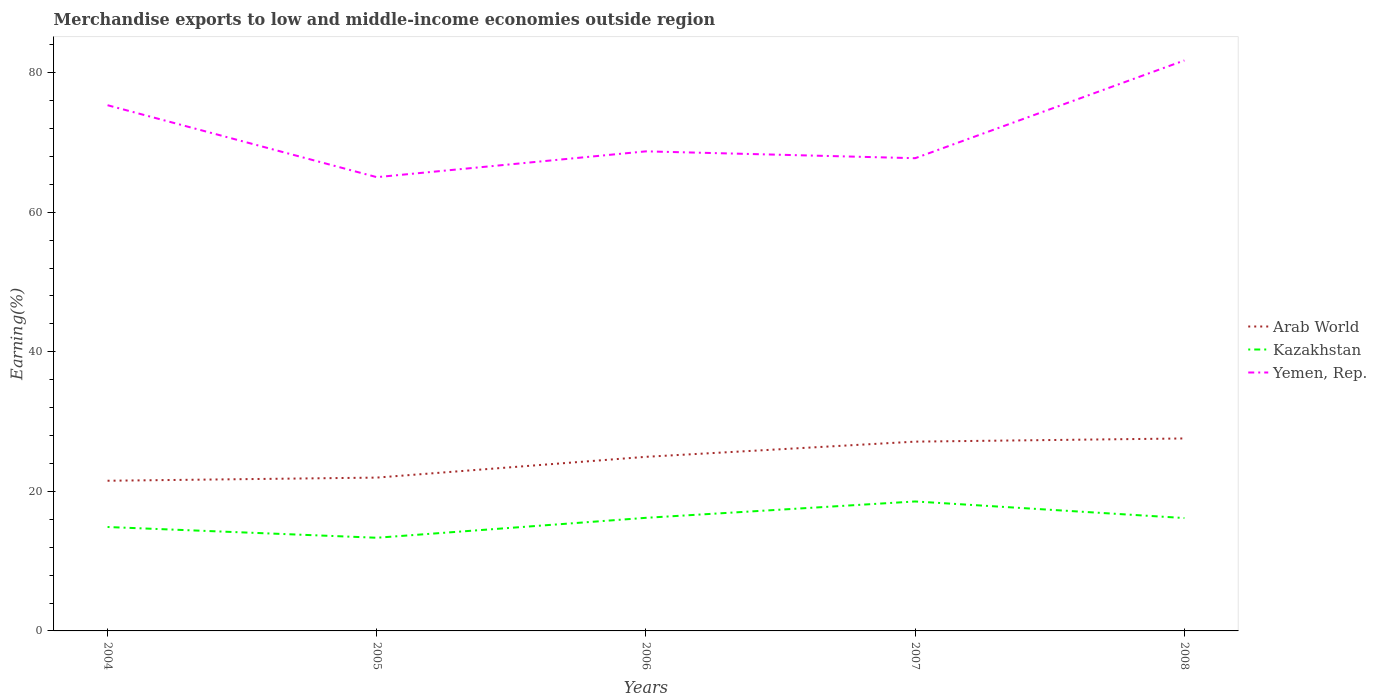How many different coloured lines are there?
Make the answer very short. 3. Does the line corresponding to Kazakhstan intersect with the line corresponding to Yemen, Rep.?
Give a very brief answer. No. Across all years, what is the maximum percentage of amount earned from merchandise exports in Arab World?
Provide a short and direct response. 21.52. In which year was the percentage of amount earned from merchandise exports in Arab World maximum?
Provide a succinct answer. 2004. What is the total percentage of amount earned from merchandise exports in Kazakhstan in the graph?
Ensure brevity in your answer.  -3.66. What is the difference between the highest and the second highest percentage of amount earned from merchandise exports in Arab World?
Give a very brief answer. 6.06. What is the difference between two consecutive major ticks on the Y-axis?
Ensure brevity in your answer.  20. Are the values on the major ticks of Y-axis written in scientific E-notation?
Your response must be concise. No. Does the graph contain any zero values?
Provide a succinct answer. No. Where does the legend appear in the graph?
Your answer should be very brief. Center right. How many legend labels are there?
Ensure brevity in your answer.  3. How are the legend labels stacked?
Keep it short and to the point. Vertical. What is the title of the graph?
Make the answer very short. Merchandise exports to low and middle-income economies outside region. Does "Latin America(developing only)" appear as one of the legend labels in the graph?
Provide a succinct answer. No. What is the label or title of the Y-axis?
Ensure brevity in your answer.  Earning(%). What is the Earning(%) in Arab World in 2004?
Keep it short and to the point. 21.52. What is the Earning(%) in Kazakhstan in 2004?
Offer a terse response. 14.89. What is the Earning(%) of Yemen, Rep. in 2004?
Give a very brief answer. 75.33. What is the Earning(%) of Arab World in 2005?
Make the answer very short. 21.97. What is the Earning(%) in Kazakhstan in 2005?
Keep it short and to the point. 13.35. What is the Earning(%) in Yemen, Rep. in 2005?
Provide a short and direct response. 65.02. What is the Earning(%) in Arab World in 2006?
Your answer should be very brief. 24.95. What is the Earning(%) in Kazakhstan in 2006?
Make the answer very short. 16.21. What is the Earning(%) in Yemen, Rep. in 2006?
Offer a very short reply. 68.72. What is the Earning(%) of Arab World in 2007?
Your answer should be compact. 27.12. What is the Earning(%) in Kazakhstan in 2007?
Your response must be concise. 18.55. What is the Earning(%) of Yemen, Rep. in 2007?
Offer a very short reply. 67.73. What is the Earning(%) in Arab World in 2008?
Ensure brevity in your answer.  27.58. What is the Earning(%) of Kazakhstan in 2008?
Your response must be concise. 16.17. What is the Earning(%) in Yemen, Rep. in 2008?
Make the answer very short. 81.74. Across all years, what is the maximum Earning(%) in Arab World?
Provide a succinct answer. 27.58. Across all years, what is the maximum Earning(%) in Kazakhstan?
Provide a succinct answer. 18.55. Across all years, what is the maximum Earning(%) of Yemen, Rep.?
Make the answer very short. 81.74. Across all years, what is the minimum Earning(%) of Arab World?
Give a very brief answer. 21.52. Across all years, what is the minimum Earning(%) in Kazakhstan?
Your response must be concise. 13.35. Across all years, what is the minimum Earning(%) of Yemen, Rep.?
Your response must be concise. 65.02. What is the total Earning(%) in Arab World in the graph?
Ensure brevity in your answer.  123.14. What is the total Earning(%) of Kazakhstan in the graph?
Your response must be concise. 79.17. What is the total Earning(%) in Yemen, Rep. in the graph?
Provide a short and direct response. 358.54. What is the difference between the Earning(%) in Arab World in 2004 and that in 2005?
Provide a succinct answer. -0.45. What is the difference between the Earning(%) of Kazakhstan in 2004 and that in 2005?
Your answer should be very brief. 1.54. What is the difference between the Earning(%) of Yemen, Rep. in 2004 and that in 2005?
Ensure brevity in your answer.  10.31. What is the difference between the Earning(%) in Arab World in 2004 and that in 2006?
Your answer should be compact. -3.43. What is the difference between the Earning(%) in Kazakhstan in 2004 and that in 2006?
Offer a very short reply. -1.32. What is the difference between the Earning(%) of Yemen, Rep. in 2004 and that in 2006?
Your response must be concise. 6.61. What is the difference between the Earning(%) of Arab World in 2004 and that in 2007?
Provide a succinct answer. -5.6. What is the difference between the Earning(%) of Kazakhstan in 2004 and that in 2007?
Make the answer very short. -3.66. What is the difference between the Earning(%) in Yemen, Rep. in 2004 and that in 2007?
Offer a terse response. 7.59. What is the difference between the Earning(%) of Arab World in 2004 and that in 2008?
Give a very brief answer. -6.06. What is the difference between the Earning(%) in Kazakhstan in 2004 and that in 2008?
Make the answer very short. -1.28. What is the difference between the Earning(%) of Yemen, Rep. in 2004 and that in 2008?
Your answer should be very brief. -6.42. What is the difference between the Earning(%) of Arab World in 2005 and that in 2006?
Provide a succinct answer. -2.98. What is the difference between the Earning(%) of Kazakhstan in 2005 and that in 2006?
Offer a terse response. -2.86. What is the difference between the Earning(%) in Yemen, Rep. in 2005 and that in 2006?
Your answer should be compact. -3.7. What is the difference between the Earning(%) of Arab World in 2005 and that in 2007?
Provide a succinct answer. -5.15. What is the difference between the Earning(%) of Kazakhstan in 2005 and that in 2007?
Provide a succinct answer. -5.2. What is the difference between the Earning(%) of Yemen, Rep. in 2005 and that in 2007?
Provide a succinct answer. -2.72. What is the difference between the Earning(%) of Arab World in 2005 and that in 2008?
Your answer should be very brief. -5.61. What is the difference between the Earning(%) in Kazakhstan in 2005 and that in 2008?
Provide a short and direct response. -2.82. What is the difference between the Earning(%) in Yemen, Rep. in 2005 and that in 2008?
Provide a short and direct response. -16.72. What is the difference between the Earning(%) in Arab World in 2006 and that in 2007?
Make the answer very short. -2.18. What is the difference between the Earning(%) of Kazakhstan in 2006 and that in 2007?
Keep it short and to the point. -2.34. What is the difference between the Earning(%) of Yemen, Rep. in 2006 and that in 2007?
Your response must be concise. 0.98. What is the difference between the Earning(%) of Arab World in 2006 and that in 2008?
Your answer should be compact. -2.63. What is the difference between the Earning(%) of Kazakhstan in 2006 and that in 2008?
Offer a very short reply. 0.03. What is the difference between the Earning(%) in Yemen, Rep. in 2006 and that in 2008?
Ensure brevity in your answer.  -13.03. What is the difference between the Earning(%) in Arab World in 2007 and that in 2008?
Ensure brevity in your answer.  -0.46. What is the difference between the Earning(%) in Kazakhstan in 2007 and that in 2008?
Your response must be concise. 2.38. What is the difference between the Earning(%) in Yemen, Rep. in 2007 and that in 2008?
Your response must be concise. -14.01. What is the difference between the Earning(%) in Arab World in 2004 and the Earning(%) in Kazakhstan in 2005?
Provide a short and direct response. 8.17. What is the difference between the Earning(%) in Arab World in 2004 and the Earning(%) in Yemen, Rep. in 2005?
Your answer should be very brief. -43.5. What is the difference between the Earning(%) of Kazakhstan in 2004 and the Earning(%) of Yemen, Rep. in 2005?
Provide a short and direct response. -50.13. What is the difference between the Earning(%) in Arab World in 2004 and the Earning(%) in Kazakhstan in 2006?
Make the answer very short. 5.31. What is the difference between the Earning(%) of Arab World in 2004 and the Earning(%) of Yemen, Rep. in 2006?
Your answer should be compact. -47.2. What is the difference between the Earning(%) of Kazakhstan in 2004 and the Earning(%) of Yemen, Rep. in 2006?
Make the answer very short. -53.83. What is the difference between the Earning(%) of Arab World in 2004 and the Earning(%) of Kazakhstan in 2007?
Keep it short and to the point. 2.97. What is the difference between the Earning(%) in Arab World in 2004 and the Earning(%) in Yemen, Rep. in 2007?
Provide a short and direct response. -46.22. What is the difference between the Earning(%) of Kazakhstan in 2004 and the Earning(%) of Yemen, Rep. in 2007?
Make the answer very short. -52.84. What is the difference between the Earning(%) of Arab World in 2004 and the Earning(%) of Kazakhstan in 2008?
Make the answer very short. 5.35. What is the difference between the Earning(%) in Arab World in 2004 and the Earning(%) in Yemen, Rep. in 2008?
Provide a succinct answer. -60.22. What is the difference between the Earning(%) of Kazakhstan in 2004 and the Earning(%) of Yemen, Rep. in 2008?
Your answer should be compact. -66.85. What is the difference between the Earning(%) in Arab World in 2005 and the Earning(%) in Kazakhstan in 2006?
Offer a very short reply. 5.76. What is the difference between the Earning(%) of Arab World in 2005 and the Earning(%) of Yemen, Rep. in 2006?
Offer a terse response. -46.75. What is the difference between the Earning(%) in Kazakhstan in 2005 and the Earning(%) in Yemen, Rep. in 2006?
Your response must be concise. -55.37. What is the difference between the Earning(%) in Arab World in 2005 and the Earning(%) in Kazakhstan in 2007?
Give a very brief answer. 3.42. What is the difference between the Earning(%) in Arab World in 2005 and the Earning(%) in Yemen, Rep. in 2007?
Offer a very short reply. -45.77. What is the difference between the Earning(%) of Kazakhstan in 2005 and the Earning(%) of Yemen, Rep. in 2007?
Your response must be concise. -54.38. What is the difference between the Earning(%) of Arab World in 2005 and the Earning(%) of Kazakhstan in 2008?
Your answer should be compact. 5.8. What is the difference between the Earning(%) of Arab World in 2005 and the Earning(%) of Yemen, Rep. in 2008?
Your answer should be very brief. -59.77. What is the difference between the Earning(%) in Kazakhstan in 2005 and the Earning(%) in Yemen, Rep. in 2008?
Offer a terse response. -68.39. What is the difference between the Earning(%) in Arab World in 2006 and the Earning(%) in Kazakhstan in 2007?
Keep it short and to the point. 6.4. What is the difference between the Earning(%) of Arab World in 2006 and the Earning(%) of Yemen, Rep. in 2007?
Ensure brevity in your answer.  -42.79. What is the difference between the Earning(%) of Kazakhstan in 2006 and the Earning(%) of Yemen, Rep. in 2007?
Keep it short and to the point. -51.53. What is the difference between the Earning(%) of Arab World in 2006 and the Earning(%) of Kazakhstan in 2008?
Give a very brief answer. 8.77. What is the difference between the Earning(%) in Arab World in 2006 and the Earning(%) in Yemen, Rep. in 2008?
Provide a short and direct response. -56.8. What is the difference between the Earning(%) of Kazakhstan in 2006 and the Earning(%) of Yemen, Rep. in 2008?
Offer a very short reply. -65.54. What is the difference between the Earning(%) in Arab World in 2007 and the Earning(%) in Kazakhstan in 2008?
Give a very brief answer. 10.95. What is the difference between the Earning(%) of Arab World in 2007 and the Earning(%) of Yemen, Rep. in 2008?
Provide a succinct answer. -54.62. What is the difference between the Earning(%) of Kazakhstan in 2007 and the Earning(%) of Yemen, Rep. in 2008?
Offer a very short reply. -63.19. What is the average Earning(%) of Arab World per year?
Provide a succinct answer. 24.63. What is the average Earning(%) of Kazakhstan per year?
Your answer should be compact. 15.83. What is the average Earning(%) of Yemen, Rep. per year?
Provide a short and direct response. 71.71. In the year 2004, what is the difference between the Earning(%) of Arab World and Earning(%) of Kazakhstan?
Provide a succinct answer. 6.63. In the year 2004, what is the difference between the Earning(%) in Arab World and Earning(%) in Yemen, Rep.?
Provide a succinct answer. -53.81. In the year 2004, what is the difference between the Earning(%) in Kazakhstan and Earning(%) in Yemen, Rep.?
Provide a succinct answer. -60.44. In the year 2005, what is the difference between the Earning(%) in Arab World and Earning(%) in Kazakhstan?
Provide a succinct answer. 8.62. In the year 2005, what is the difference between the Earning(%) in Arab World and Earning(%) in Yemen, Rep.?
Keep it short and to the point. -43.05. In the year 2005, what is the difference between the Earning(%) of Kazakhstan and Earning(%) of Yemen, Rep.?
Your answer should be very brief. -51.67. In the year 2006, what is the difference between the Earning(%) in Arab World and Earning(%) in Kazakhstan?
Keep it short and to the point. 8.74. In the year 2006, what is the difference between the Earning(%) of Arab World and Earning(%) of Yemen, Rep.?
Ensure brevity in your answer.  -43.77. In the year 2006, what is the difference between the Earning(%) in Kazakhstan and Earning(%) in Yemen, Rep.?
Ensure brevity in your answer.  -52.51. In the year 2007, what is the difference between the Earning(%) of Arab World and Earning(%) of Kazakhstan?
Offer a terse response. 8.57. In the year 2007, what is the difference between the Earning(%) in Arab World and Earning(%) in Yemen, Rep.?
Provide a succinct answer. -40.61. In the year 2007, what is the difference between the Earning(%) in Kazakhstan and Earning(%) in Yemen, Rep.?
Your response must be concise. -49.18. In the year 2008, what is the difference between the Earning(%) in Arab World and Earning(%) in Kazakhstan?
Your response must be concise. 11.41. In the year 2008, what is the difference between the Earning(%) in Arab World and Earning(%) in Yemen, Rep.?
Keep it short and to the point. -54.16. In the year 2008, what is the difference between the Earning(%) of Kazakhstan and Earning(%) of Yemen, Rep.?
Provide a succinct answer. -65.57. What is the ratio of the Earning(%) of Arab World in 2004 to that in 2005?
Provide a succinct answer. 0.98. What is the ratio of the Earning(%) in Kazakhstan in 2004 to that in 2005?
Make the answer very short. 1.12. What is the ratio of the Earning(%) in Yemen, Rep. in 2004 to that in 2005?
Your answer should be very brief. 1.16. What is the ratio of the Earning(%) of Arab World in 2004 to that in 2006?
Offer a very short reply. 0.86. What is the ratio of the Earning(%) of Kazakhstan in 2004 to that in 2006?
Give a very brief answer. 0.92. What is the ratio of the Earning(%) of Yemen, Rep. in 2004 to that in 2006?
Offer a terse response. 1.1. What is the ratio of the Earning(%) of Arab World in 2004 to that in 2007?
Your answer should be compact. 0.79. What is the ratio of the Earning(%) of Kazakhstan in 2004 to that in 2007?
Your response must be concise. 0.8. What is the ratio of the Earning(%) of Yemen, Rep. in 2004 to that in 2007?
Your answer should be compact. 1.11. What is the ratio of the Earning(%) of Arab World in 2004 to that in 2008?
Offer a very short reply. 0.78. What is the ratio of the Earning(%) in Kazakhstan in 2004 to that in 2008?
Make the answer very short. 0.92. What is the ratio of the Earning(%) of Yemen, Rep. in 2004 to that in 2008?
Provide a succinct answer. 0.92. What is the ratio of the Earning(%) of Arab World in 2005 to that in 2006?
Give a very brief answer. 0.88. What is the ratio of the Earning(%) of Kazakhstan in 2005 to that in 2006?
Offer a very short reply. 0.82. What is the ratio of the Earning(%) in Yemen, Rep. in 2005 to that in 2006?
Offer a terse response. 0.95. What is the ratio of the Earning(%) of Arab World in 2005 to that in 2007?
Your answer should be compact. 0.81. What is the ratio of the Earning(%) in Kazakhstan in 2005 to that in 2007?
Provide a short and direct response. 0.72. What is the ratio of the Earning(%) in Yemen, Rep. in 2005 to that in 2007?
Your answer should be very brief. 0.96. What is the ratio of the Earning(%) in Arab World in 2005 to that in 2008?
Make the answer very short. 0.8. What is the ratio of the Earning(%) in Kazakhstan in 2005 to that in 2008?
Your answer should be very brief. 0.83. What is the ratio of the Earning(%) in Yemen, Rep. in 2005 to that in 2008?
Keep it short and to the point. 0.8. What is the ratio of the Earning(%) of Arab World in 2006 to that in 2007?
Make the answer very short. 0.92. What is the ratio of the Earning(%) in Kazakhstan in 2006 to that in 2007?
Your answer should be compact. 0.87. What is the ratio of the Earning(%) in Yemen, Rep. in 2006 to that in 2007?
Provide a succinct answer. 1.01. What is the ratio of the Earning(%) of Arab World in 2006 to that in 2008?
Offer a very short reply. 0.9. What is the ratio of the Earning(%) in Yemen, Rep. in 2006 to that in 2008?
Keep it short and to the point. 0.84. What is the ratio of the Earning(%) of Arab World in 2007 to that in 2008?
Offer a terse response. 0.98. What is the ratio of the Earning(%) in Kazakhstan in 2007 to that in 2008?
Give a very brief answer. 1.15. What is the ratio of the Earning(%) in Yemen, Rep. in 2007 to that in 2008?
Keep it short and to the point. 0.83. What is the difference between the highest and the second highest Earning(%) of Arab World?
Provide a short and direct response. 0.46. What is the difference between the highest and the second highest Earning(%) of Kazakhstan?
Your answer should be compact. 2.34. What is the difference between the highest and the second highest Earning(%) in Yemen, Rep.?
Your answer should be compact. 6.42. What is the difference between the highest and the lowest Earning(%) in Arab World?
Your response must be concise. 6.06. What is the difference between the highest and the lowest Earning(%) of Kazakhstan?
Ensure brevity in your answer.  5.2. What is the difference between the highest and the lowest Earning(%) of Yemen, Rep.?
Provide a short and direct response. 16.72. 